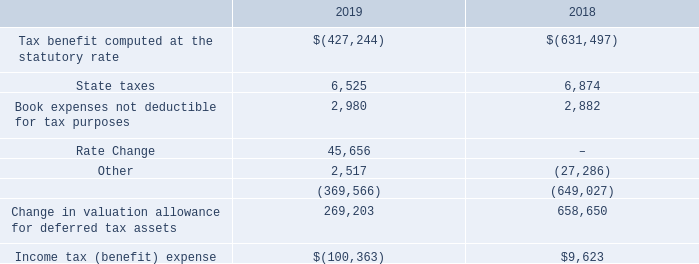NOTE L – INCOME TAXES
On December 22, 2017, the U.S. government enacted comprehensive tax legislation commonly referred to as the Tax Cuts and Jobs Act (the “Tax Act”). The Tax Act makes broad and complex changes to the U.S. tax code, including, but not limited to, the following that impact the Company: (1) reducing the U.S. federal corporate income tax rate from 35 percent to 21 percent; (2) eliminating the corporate alternative minimum tax; (3) creating a new limitation on deductible interest expense; (4) limiting the deductibility of certain executive compensation; and (5) limiting certain other deductions.
The Company follows ASC 740-10 “Income Taxes” which requires the recognition of deferred tax liabilities and assets for the expected future tax consequences of events that have been included in the financial statement or tax returns. Under this method, deferred tax liabilities and assets are determined based on the difference between financial statements and tax bases of assets and liabilities using enacted tax rates in effect for the year in which the differences are expected to reverse.
A reconciliation of tax expense computed at the statutory federal tax rate on loss from operations before income taxes to the actual income tax (benefit) /expense is as follows:
Which guide does the Company follow to determine their deferred tax liabilities and assets? Asc 740-10 “income taxes”. What is the income tax benefit in 2019? 100,363. What is the change in valuation allowance for deferred tax assets in 2018? 658,650. What is the change in state taxes from 2018 to 2019? 6,525-6,874
Answer: -349. What is the percentage change in Book expenses not deductible for tax purposes from 2018 to 2019?
Answer scale should be: percent. (2,980-2,882)/2,882
Answer: 3.4. What is the percentage change in the Tax benefit computed at the statutory rate from 2018 to 2019?
Answer scale should be: percent. (427,244-631,497)/631,497
Answer: -32.34. 